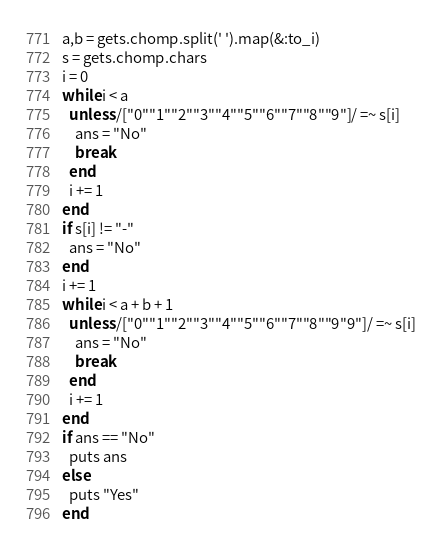<code> <loc_0><loc_0><loc_500><loc_500><_Ruby_>a,b = gets.chomp.split(' ').map(&:to_i)
s = gets.chomp.chars
i = 0
while i < a
  unless /["0""1""2""3""4""5""6""7""8""9"]/ =~ s[i]
    ans = "No"
    break
  end
  i += 1
end
if s[i] != "-"
  ans = "No"
end
i += 1
while i < a + b + 1
  unless /["0""1""2""3""4""5""6""7""8""9"9"]/ =~ s[i]
    ans = "No"
    break
  end
  i += 1
end
if ans == "No"
  puts ans
else
  puts "Yes"
end
</code> 